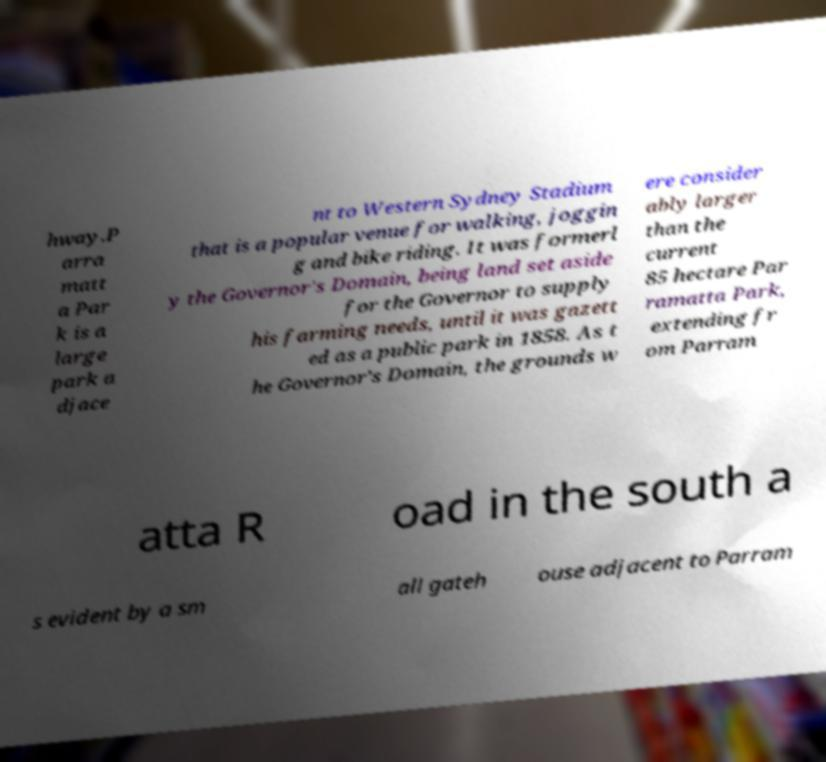I need the written content from this picture converted into text. Can you do that? hway.P arra matt a Par k is a large park a djace nt to Western Sydney Stadium that is a popular venue for walking, joggin g and bike riding. It was formerl y the Governor's Domain, being land set aside for the Governor to supply his farming needs, until it was gazett ed as a public park in 1858. As t he Governor's Domain, the grounds w ere consider ably larger than the current 85 hectare Par ramatta Park, extending fr om Parram atta R oad in the south a s evident by a sm all gateh ouse adjacent to Parram 